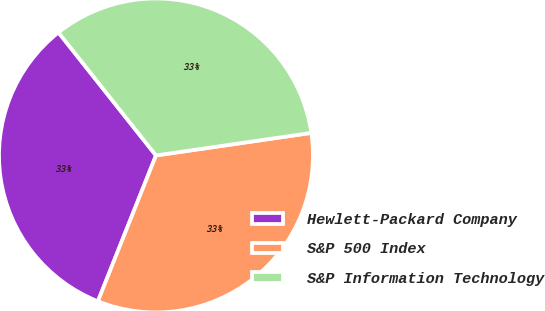Convert chart to OTSL. <chart><loc_0><loc_0><loc_500><loc_500><pie_chart><fcel>Hewlett-Packard Company<fcel>S&P 500 Index<fcel>S&P Information Technology<nl><fcel>33.3%<fcel>33.33%<fcel>33.37%<nl></chart> 